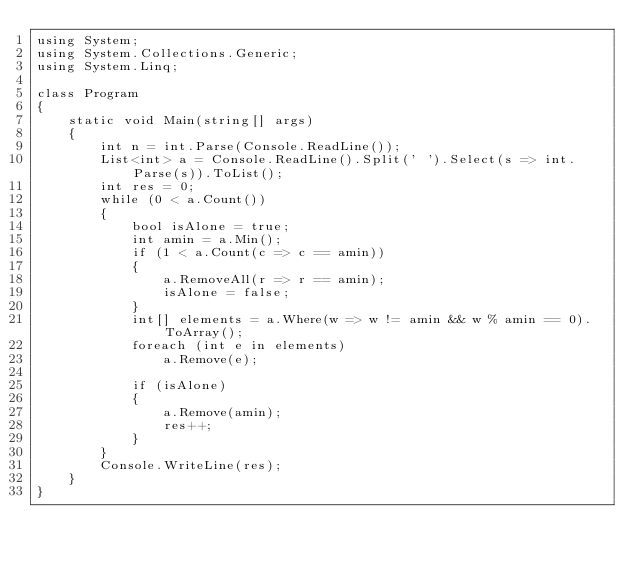Convert code to text. <code><loc_0><loc_0><loc_500><loc_500><_C#_>using System;
using System.Collections.Generic;
using System.Linq;

class Program
{
    static void Main(string[] args)
    {
        int n = int.Parse(Console.ReadLine());
        List<int> a = Console.ReadLine().Split(' ').Select(s => int.Parse(s)).ToList();
        int res = 0;
        while (0 < a.Count())
        {
            bool isAlone = true;
            int amin = a.Min();
            if (1 < a.Count(c => c == amin))
            {
                a.RemoveAll(r => r == amin);
                isAlone = false;
            }
            int[] elements = a.Where(w => w != amin && w % amin == 0).ToArray();
            foreach (int e in elements)
                a.Remove(e);
            
            if (isAlone)
            {
                a.Remove(amin);
                res++;
            }
        }
        Console.WriteLine(res);
    }
}</code> 